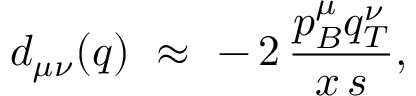<formula> <loc_0><loc_0><loc_500><loc_500>d _ { \mu \nu } ( q ) \, \approx \, - \, 2 \, \frac { p _ { B } ^ { \mu } q _ { T } ^ { \nu } } { x \, s } ,</formula> 